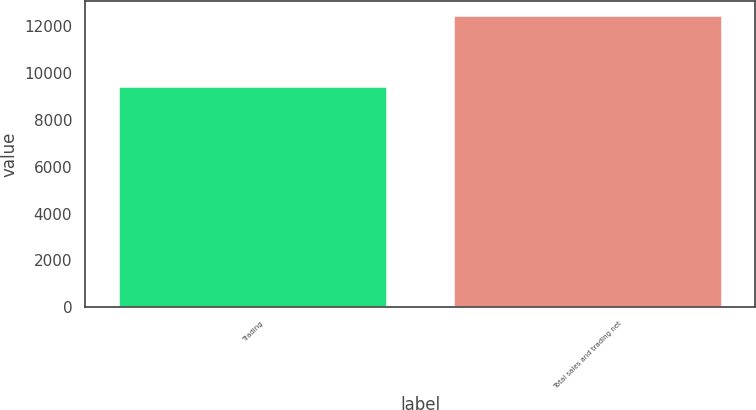Convert chart to OTSL. <chart><loc_0><loc_0><loc_500><loc_500><bar_chart><fcel>Trading<fcel>Total sales and trading net<nl><fcel>9400<fcel>12450<nl></chart> 